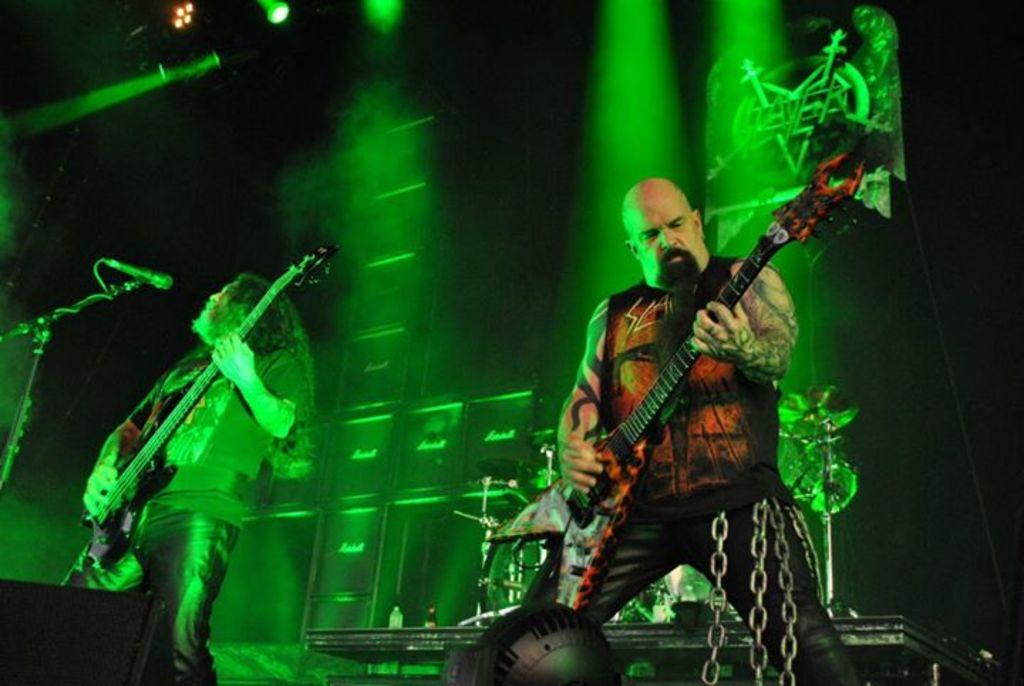How many people are in the image? There are two people in the image. What are the two people doing? The two people are playing guitar. What else can be seen in the background besides the people? There are musical instruments and a mic stand in the background. What can be seen illuminated by the lights in the image? The lights are visible in the image, but it is not clear what they are illuminating. Can you see any sea creatures swimming near the people in the image? There is no reference to a sea or any sea creatures in the image, so it is not possible to answer that question. 